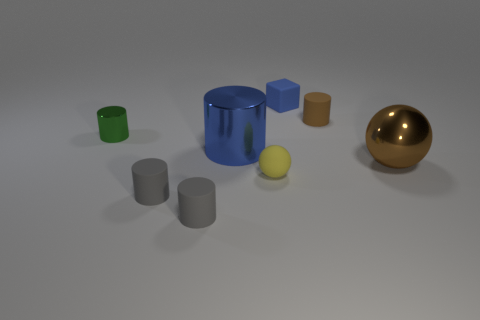What number of things are tiny cyan rubber cubes or large cylinders?
Your response must be concise. 1. What shape is the yellow thing?
Your response must be concise. Sphere. There is a green metallic thing that is the same shape as the small brown matte object; what is its size?
Offer a terse response. Small. There is a metallic object in front of the blue thing to the left of the tiny yellow thing; what size is it?
Offer a terse response. Large. Are there an equal number of brown cylinders behind the tiny brown thing and large brown things?
Give a very brief answer. No. How many other objects are there of the same color as the big metallic cylinder?
Provide a succinct answer. 1. Is the number of small yellow matte balls on the left side of the big blue metal thing less than the number of small gray metallic cylinders?
Keep it short and to the point. No. Are there any matte cylinders that have the same size as the blue metal cylinder?
Your answer should be very brief. No. Do the big cylinder and the rubber thing that is behind the brown rubber object have the same color?
Make the answer very short. Yes. There is a ball that is behind the small yellow rubber sphere; what number of big things are behind it?
Your answer should be compact. 1. 